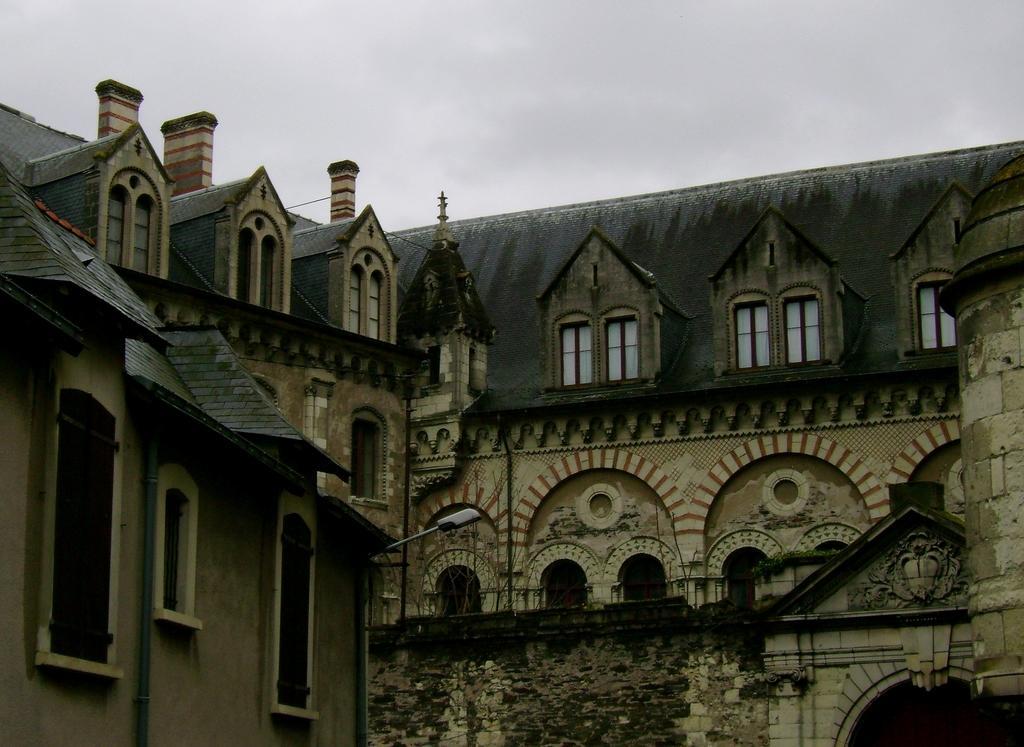Could you give a brief overview of what you see in this image? In this picture there is a building in the center of the image and there are windows on it, there is a lamp pole in the image and there is sky at the top side of the image. 